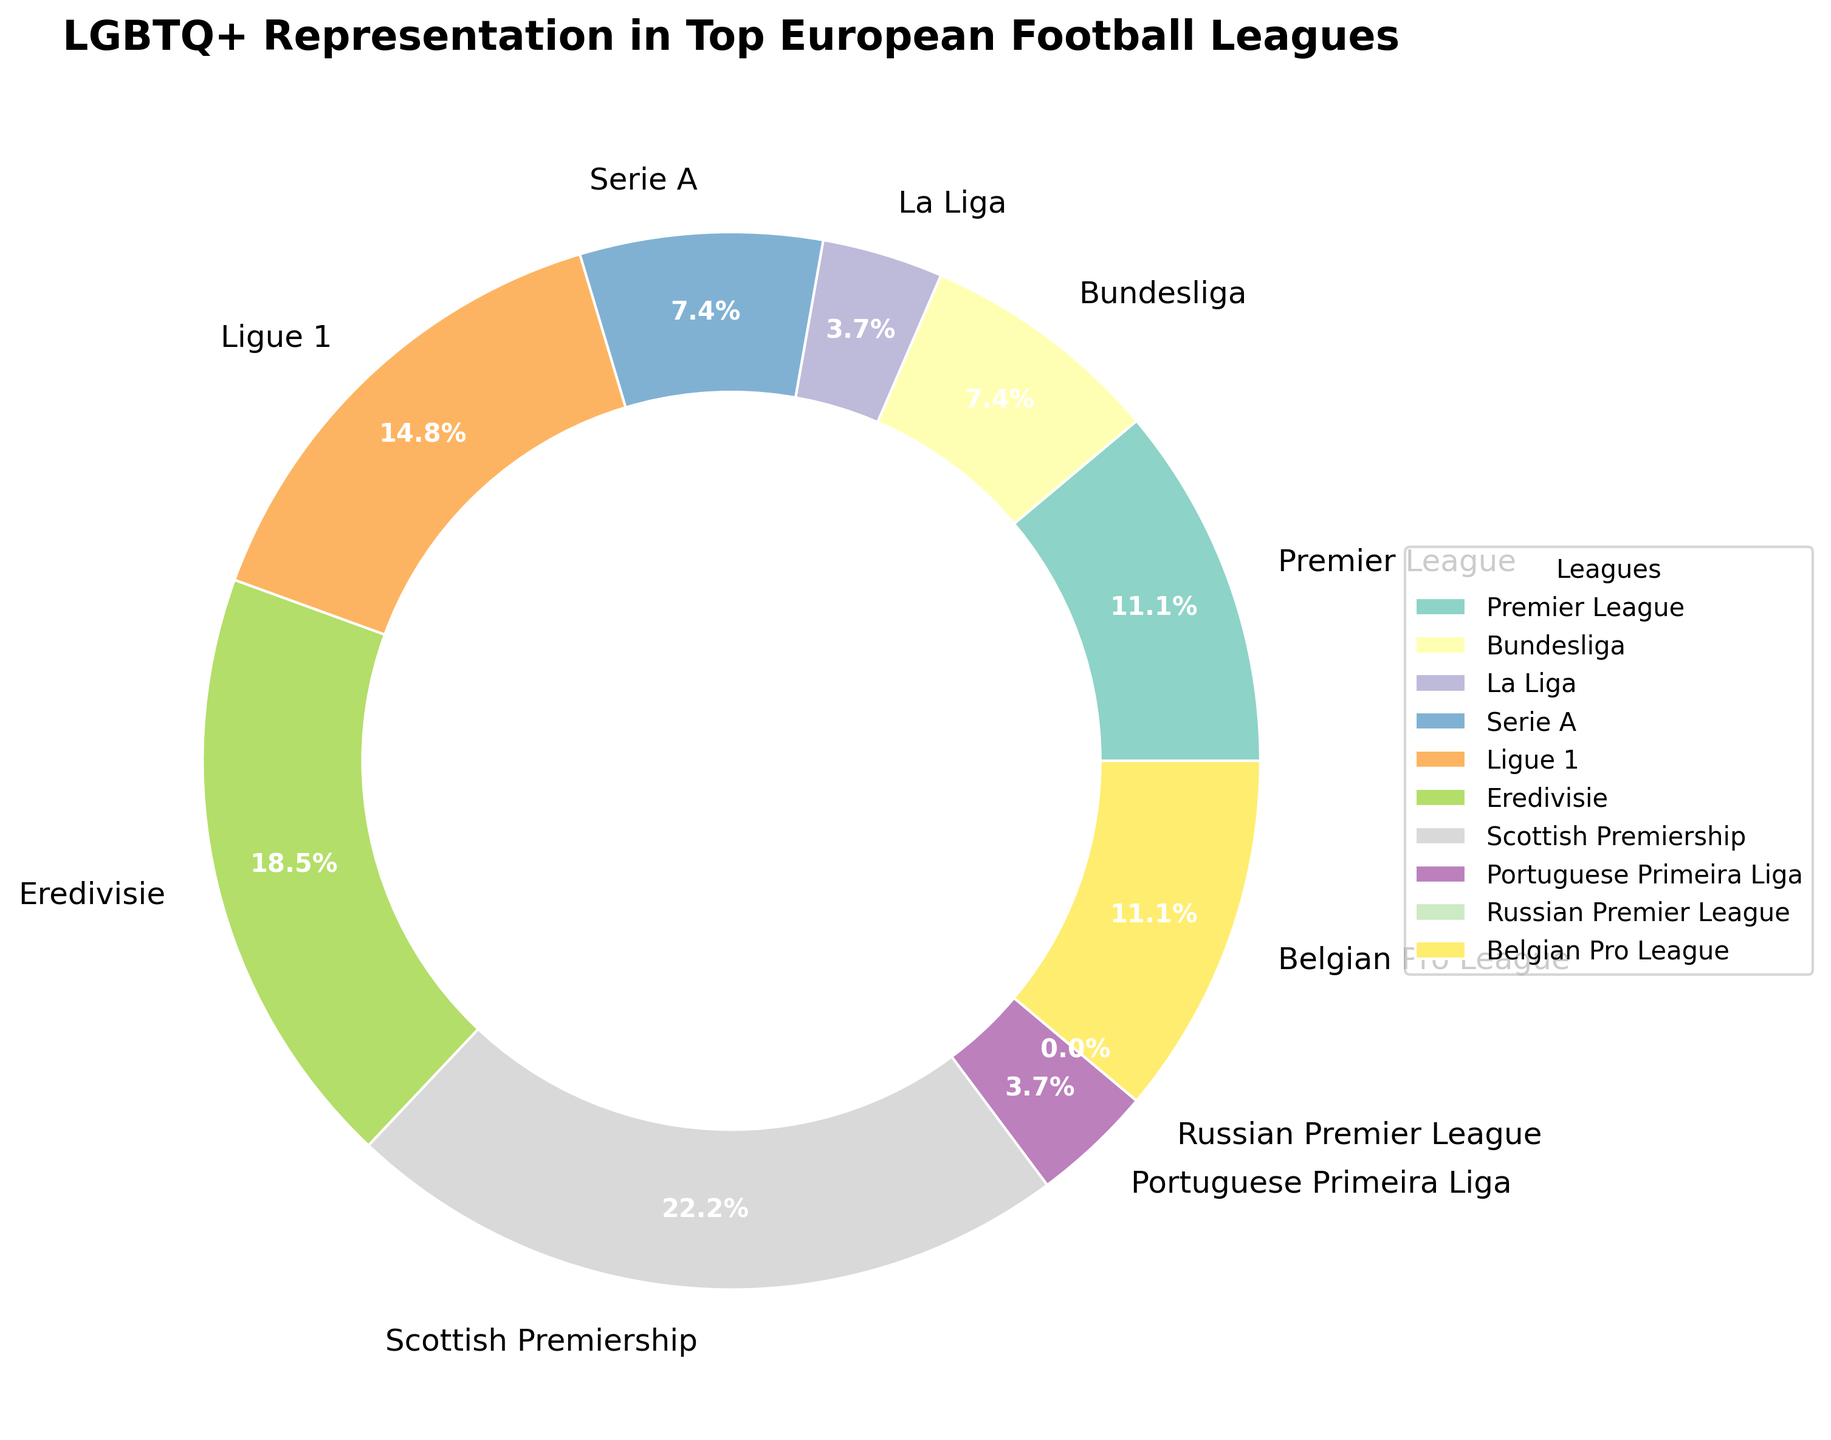Which league has the highest percentage of out LGBTQ+ players? The Eredivisie has the highest percentage of out LGBTQ+ players at 0.5%.
Answer: Eredivisie Which two leagues have equal percentages of out LGBTQ+ players? Both the Bundesliga and Serie A have 0.2% of out LGBTQ+ players.
Answer: Bundesliga, Serie A How does the percentage of out LGBTQ+ players in the Premier League compare to the Portuguese Primeira Liga? The Premier League has 0.3%, while the Portuguese Primeira Liga has 0.1%. Hence, the Premier League has a higher percentage.
Answer: Premier League What is the total percentage of out LGBTQ+ players for La Liga and the Russian Premier League combined? La Liga has 0.1% and the Russian Premier League has 0.0%. Adding these together gives 0.1%.
Answer: 0.1% Which leagues have less than 0.3% of out LGBTQ+ players? La Liga, Bundesliga, Serie A, and Portuguese Primeira Liga each have less than 0.3%.
Answer: La Liga, Bundesliga, Serie A, Portuguese Primeira Liga Which league has the smallest percentage of out LGBTQ+ players and what is that percentage? The Russian Premier League has the smallest percentage of out LGBTQ+ players at 0.0%.
Answer: Russian Premier League What is the average percentage of out LGBTQ+ players in the Premier League, Bundesliga, and Serie A? The Premier League has 0.3%, the Bundesliga has 0.2%, and Serie A has 0.2%. The average is (0.3 + 0.2 + 0.2) / 3 = 0.233%.
Answer: 0.233% Rank the leagues from highest to lowest percentage of out LGBTQ+ players. The ranking goes: Eredivisie, Scottish Premiership, Ligue 1, Premier League, Belgian Pro League, Bundesliga, Serie A, La Liga, Portuguese Primeira Liga, Russian Premier League.
Answer: Eredivisie, Scottish Premiership, Ligue 1, Premier League, Belgian Pro League, Bundesliga, Serie A, La Liga, Portuguese Primeira Liga, Russian Premier League What is the difference in the percentage of out LGBTQ+ players between the Eredivisie and La Liga? Eredivisie has 0.5% while La Liga has 0.1%. The difference is 0.5% - 0.1% = 0.4%.
Answer: 0.4% What colors are used for the Premier League and La Liga wedges in the pie chart? According to the legend next to the pie chart, the Premier League wedge is shown in a specific color (for example, blue), and La Liga is another distinctive color (for example, red).
Answer: Premier League: Blue, La Liga: Red 